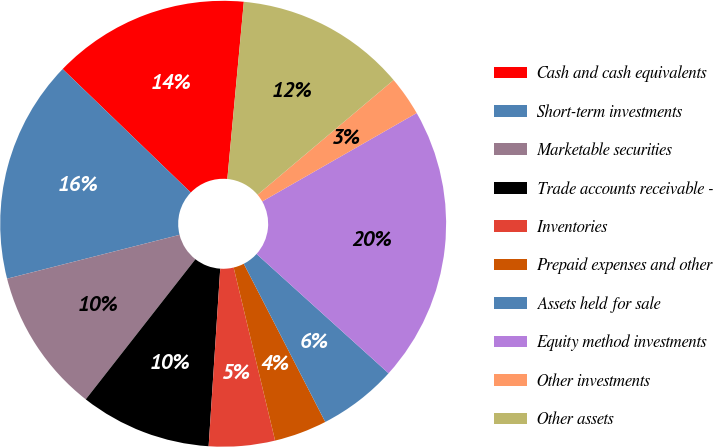<chart> <loc_0><loc_0><loc_500><loc_500><pie_chart><fcel>Cash and cash equivalents<fcel>Short-term investments<fcel>Marketable securities<fcel>Trade accounts receivable -<fcel>Inventories<fcel>Prepaid expenses and other<fcel>Assets held for sale<fcel>Equity method investments<fcel>Other investments<fcel>Other assets<nl><fcel>14.27%<fcel>16.17%<fcel>10.47%<fcel>9.53%<fcel>4.78%<fcel>3.83%<fcel>5.73%<fcel>19.97%<fcel>2.88%<fcel>12.37%<nl></chart> 